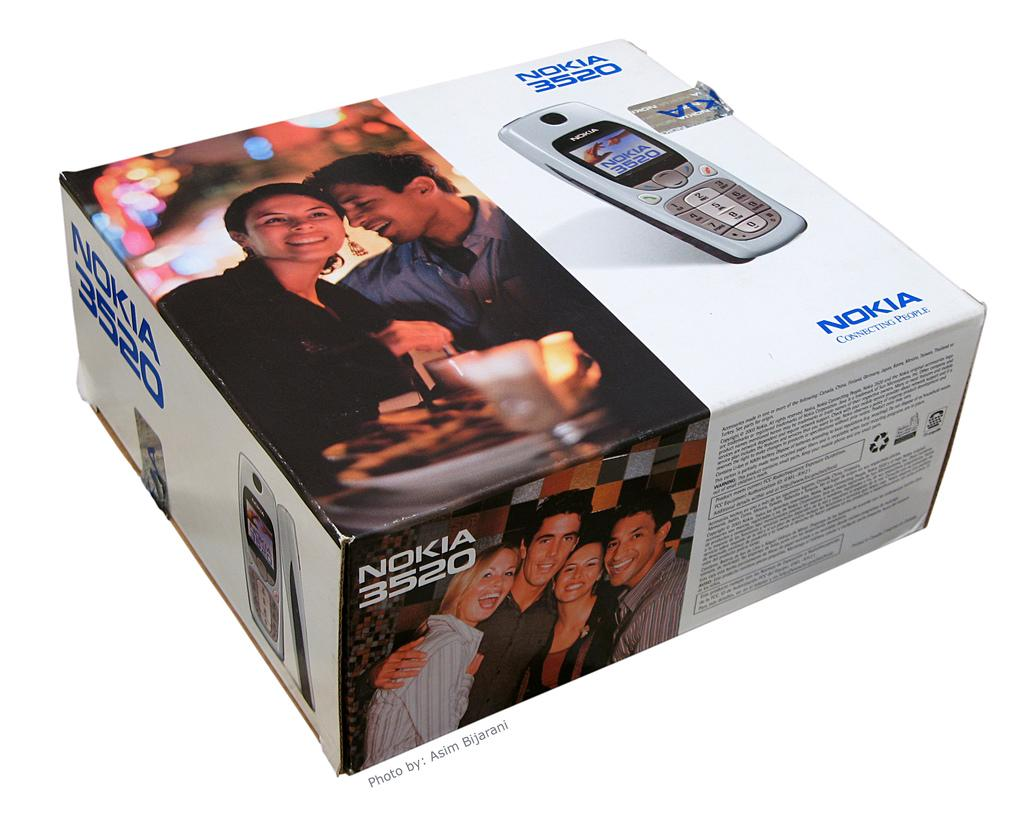What types of people are depicted in the pictures in the image? There are pictures of a man and a woman in the image. What other object is shown in the pictures? There is a picture of a cellphone in the image. Where are the pictures located? The pictures are on a box. What color is the stocking on the top of the box in the image? There is no stocking present on the top of the box in the image. 